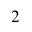<formula> <loc_0><loc_0><loc_500><loc_500>_ { 2 }</formula> 